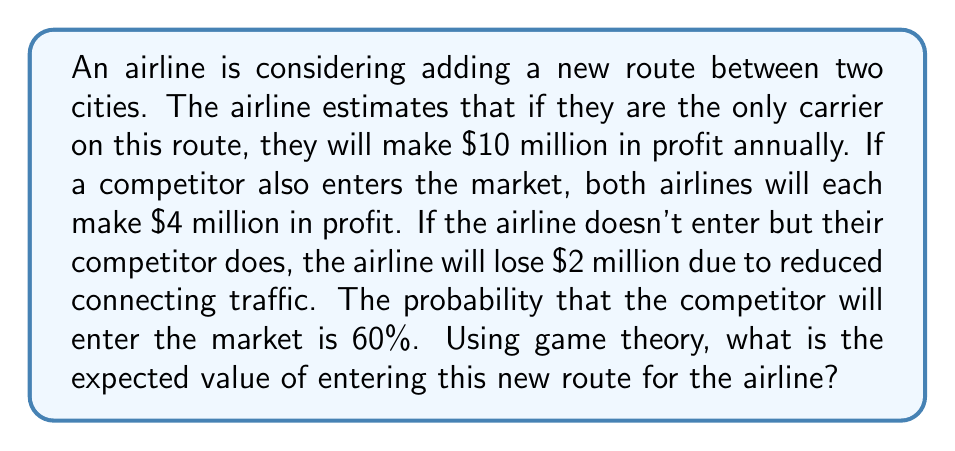Help me with this question. To solve this problem, we need to use the concept of expected value from game theory. Let's break it down step-by-step:

1) First, let's define our possible outcomes:
   - Airline enters, competitor doesn't: $10 million profit
   - Both enter: $4 million profit
   - Airline doesn't enter, competitor does: $2 million loss
   - Neither enters: $0 (no change)

2) We're given that the probability of the competitor entering is 60%, so the probability of them not entering is 40%.

3) Now, let's calculate the expected value of entering:
   
   $$E(\text{enter}) = 0.4 \cdot 10 + 0.6 \cdot 4 = 4 + 2.4 = 6.4$$

   This means if the airline enters, they can expect an average profit of $6.4 million.

4) For comparison, let's calculate the expected value of not entering:
   
   $$E(\text{not enter}) = 0.4 \cdot 0 + 0.6 \cdot (-2) = 0 - 1.2 = -1.2$$

   If the airline doesn't enter, they can expect an average loss of $1.2 million.

5) The difference between these two expected values is:

   $$6.4 - (-1.2) = 7.6$$

Therefore, the expected value of entering this new route for the airline is $6.4 million, which is $7.6 million better than not entering.
Answer: $6.4 million 